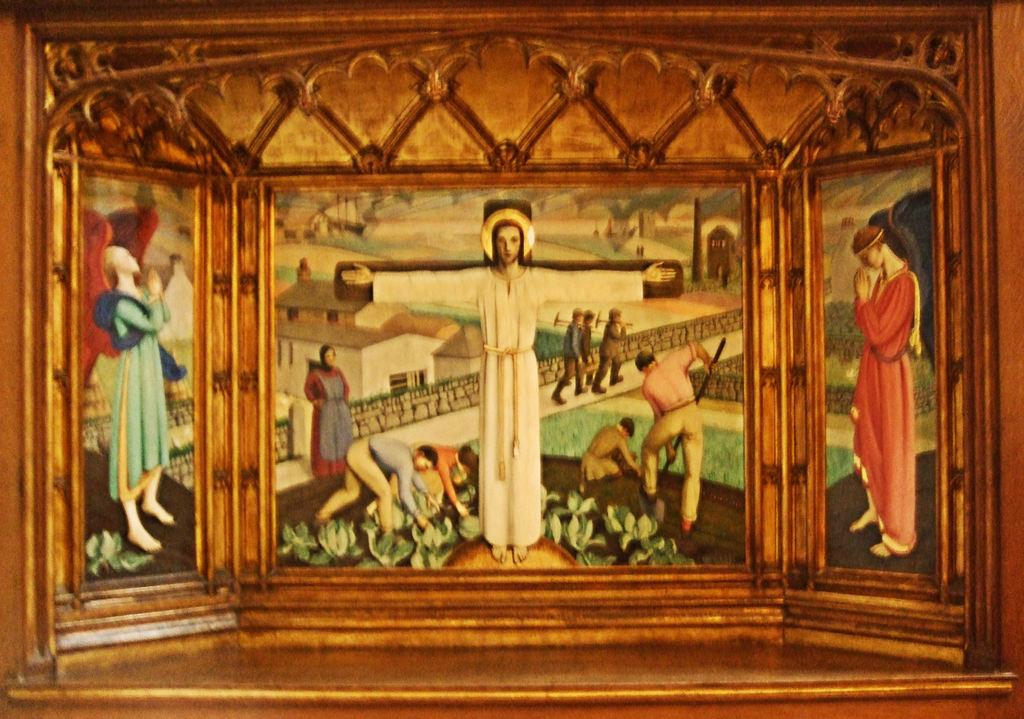What type of image is depicted in the frame? The image appears to be a frame containing paintings of idols. What can be seen in the background of the frame? In the background, there are persons working, a woman standing, people walking on a side path, and houses visible. What type of flower can be seen growing near the lake in the image? There is no lake or flower present in the image; it features a frame with paintings of idols and a background with people and houses. 